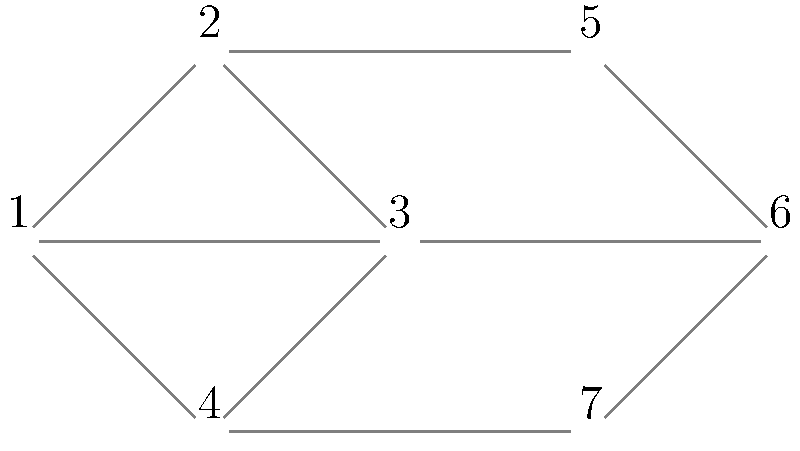In a public dispute involving multiple stakeholders, you've mapped out their relationships using graph coloring. The graph represents stakeholders as vertices, and edges connect stakeholders with conflicting interests. What is the chromatic number of this graph, and how does this information help in managing the public dispute? To determine the chromatic number and understand its implications for managing the public dispute, let's follow these steps:

1. Understand the graph:
   - The graph has 7 vertices (stakeholders) and 10 edges (conflicts).
   - Each edge represents a conflict between two stakeholders.

2. Analyze the graph structure:
   - The graph is not a complete graph, as not all vertices are connected.
   - There are no obvious symmetries or patterns that simplify coloring.

3. Apply the greedy coloring algorithm:
   - Start with vertex 1: Assign color 1
   - Vertex 2: Connected to 1, assign color 2
   - Vertex 3: Connected to 1 and 2, assign color 3
   - Vertex 4: Connected to 1 and 3, assign color 2
   - Vertex 5: Connected to 2, assign color 1
   - Vertex 6: Connected to 3 and 5, assign color 2
   - Vertex 7: Connected to 4 and 6, assign color 1

4. Count the number of colors used:
   - The greedy algorithm used 3 colors.
   - This is an upper bound for the chromatic number.

5. Verify if fewer colors are possible:
   - The graph contains a triangle (vertices 1, 2, and 3).
   - A triangle requires at least 3 colors.
   - Therefore, the chromatic number is exactly 3.

6. Interpret the result for managing the public dispute:
   - The chromatic number of 3 indicates that stakeholders can be divided into three groups with no internal conflicts.
   - This grouping can help in organizing negotiations or mediation sessions.
   - It allows for efficient communication strategies by addressing each group separately.
   - The PR team can tailor messages to each group, considering their specific concerns and relationships.
   - This approach minimizes the risk of exacerbating conflicts within each group.

By using graph coloring to analyze the stakeholder relationships, you can develop more effective strategies for managing the public dispute and minimizing its impact on your employer's reputation.
Answer: Chromatic number: 3. Helps organize stakeholders into non-conflicting groups for targeted communication and negotiation strategies. 